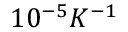<formula> <loc_0><loc_0><loc_500><loc_500>1 0 ^ { - 5 } K ^ { - 1 }</formula> 